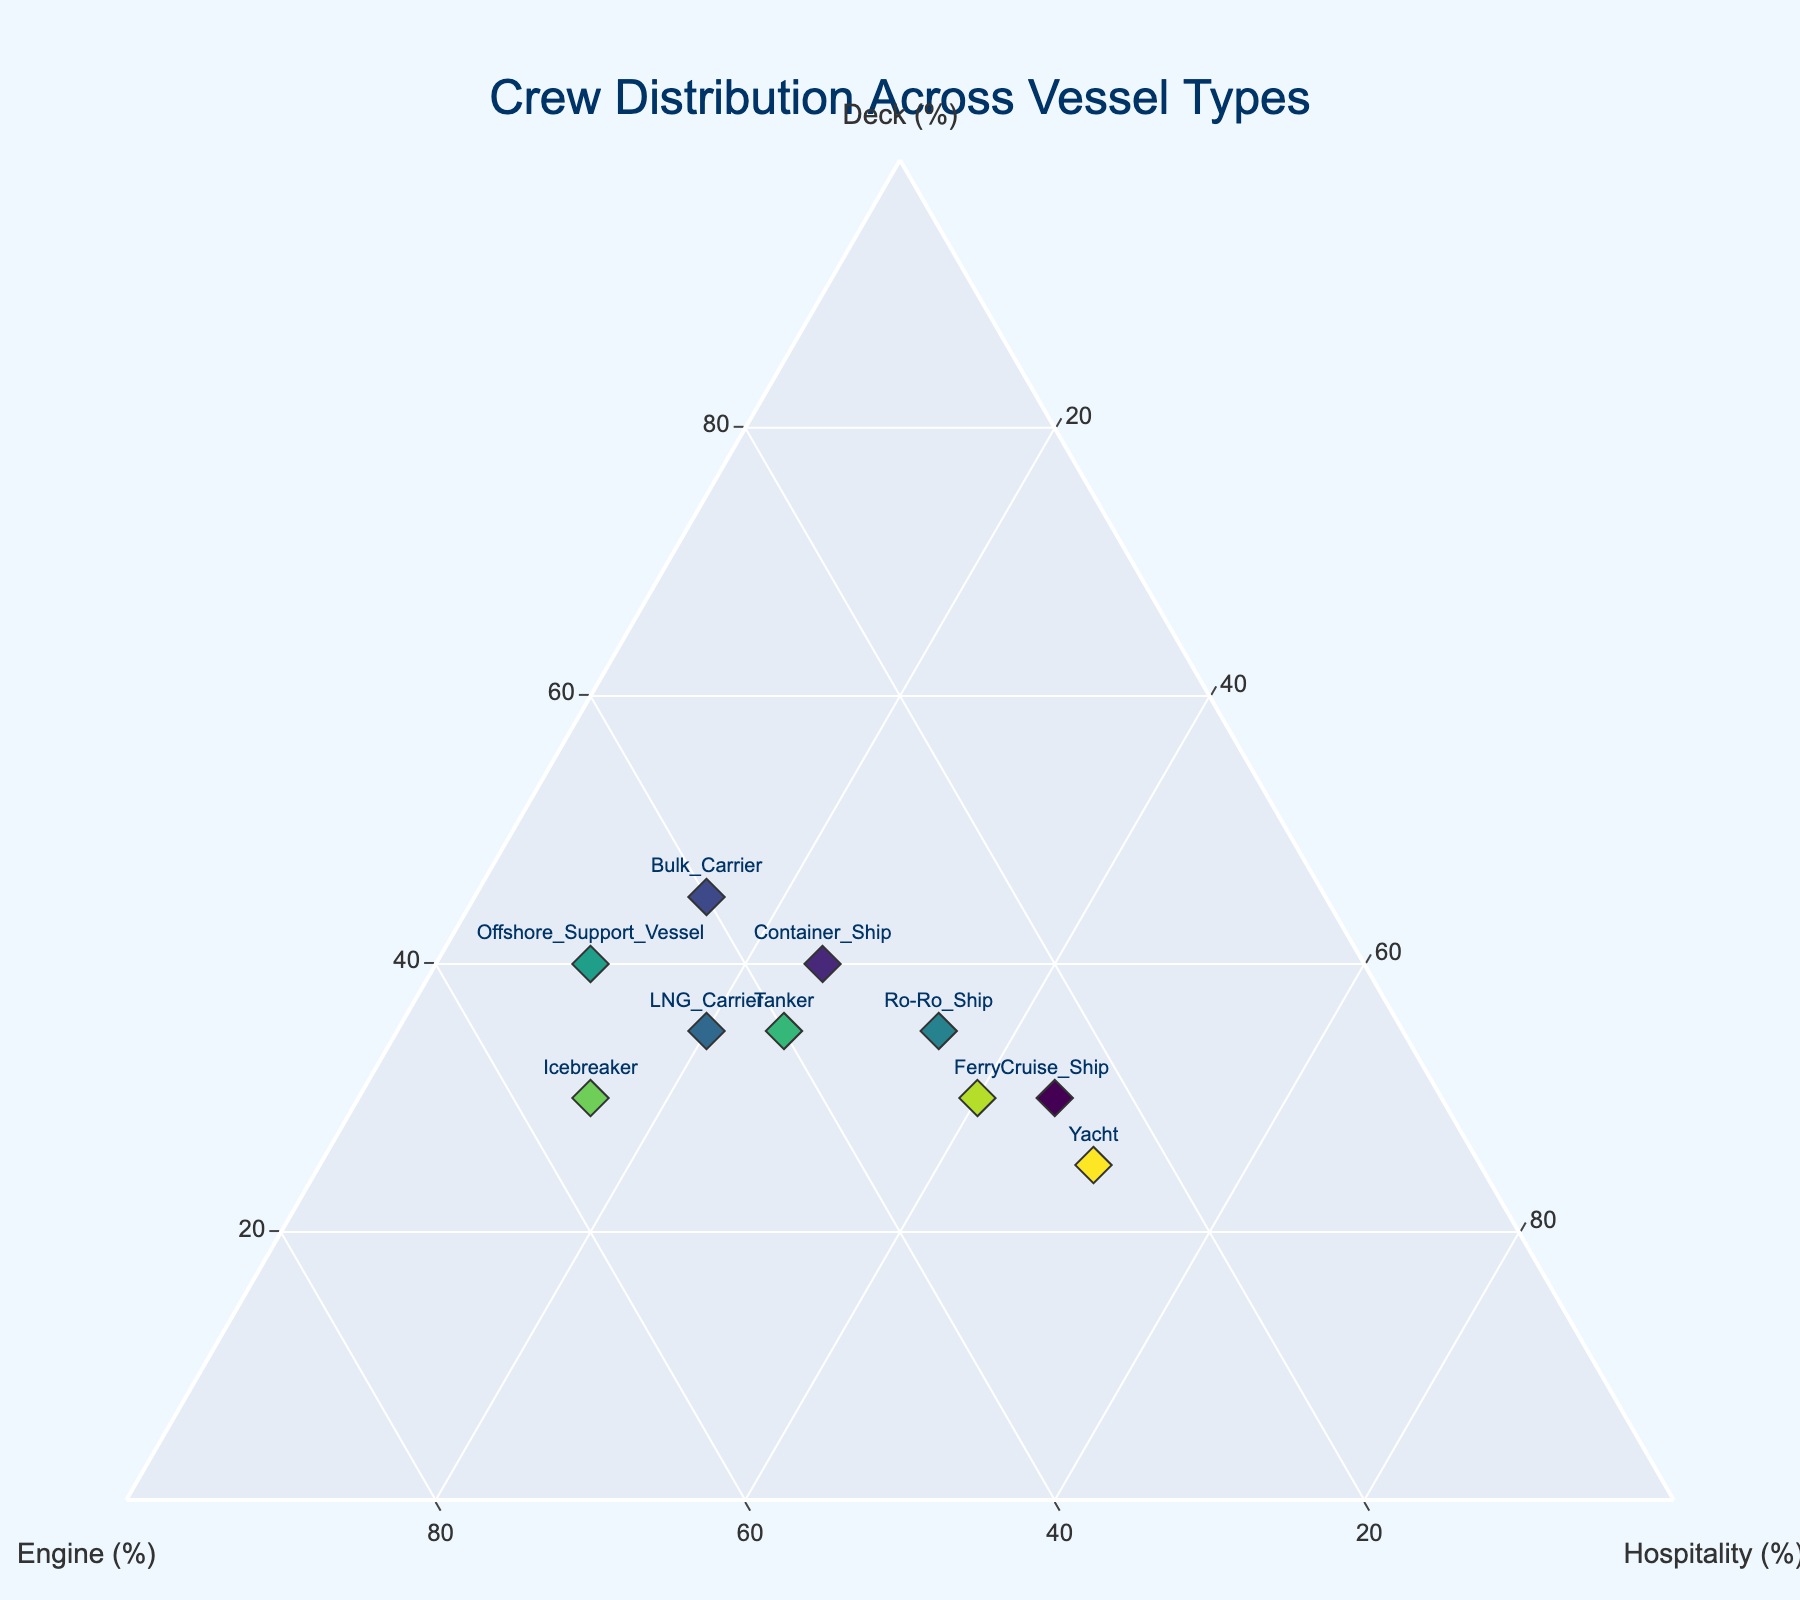How many vessel types are represented in the plot? Count the number of unique vessel types listed in the plot.
Answer: 10 What is the range of values along the "Deck (%)" axis? The "Deck (%)" axis ranges from 0% to 100%, as indicated by the ternary plot configuration.
Answer: 0% to 100% Which vessel type has the highest percentage of engine crew? Locate the point farthest along the "Engine (%)" axis. In this case, it's the Icebreaker with 55% engine crew.
Answer: Icebreaker Which vessel types have an equal percentage distribution between deck and engine crew? Look for points along the line where the percentage values of deck and engine crew are equal. In this case, it's the Ferry and Yacht, both with 30% Deck and 30% Engine, and 25% Deck and 25% Engine, respectively.
Answer: Ferry and Yacht Which vessel type has the lowest percentage of hospitality crew? Locate the point closest to the "Hospitality (%)" zero mark. In this instance, it is the Offshore Support Vessel with 10% hospitality crew.
Answer: Offshore Support Vessel What is the combined percentage of deck and engine crew for the Bulk Carrier? Add the deck and engine percentages for the Bulk Carrier: 45% (deck) + 40% (engine) = 85%.
Answer: 85% Between the Ro-Ro Ship and the Tanker, which has a higher proportion of hospitality crew? Compare the hospitality percentage values for both vessels. The Ro-Ro Ship has 35% hospitality crew, while the Tanker has 25%.
Answer: Ro-Ro Ship How does the crew distribution of LNG Carrier compare to the Icebreaker in terms of deck and engine crew? Compare each vessel's distribution: LNG Carrier has 35% deck and 45% engine crew while Icebreaker has 30% deck and 55% engine crew. The Icebreaker has more engine crew and fewer deck crew than the LNG Carrier.
Answer: Icebreaker has more engine crew and fewer deck crew If you were to average the hospitality crew percentage across all vessel types, what would it be? Sum the hospitality percentages for all vessel types and divide by the number of types. (45+25+15+20+35+10+25+15+40+50) / 10 = 280 / 10 = 28%.
Answer: 28% Considering the ternary plot, where would you place a vessel type that has a balanced distribution of 33.33% crew members in each category? A balanced distribution would place a point exactly equidistant from the three axes' vertices, creating an equilateral triangle. This point will be around the central area of the plot where the three axes intersect at equal proportions.
Answer: Central area of the plot 